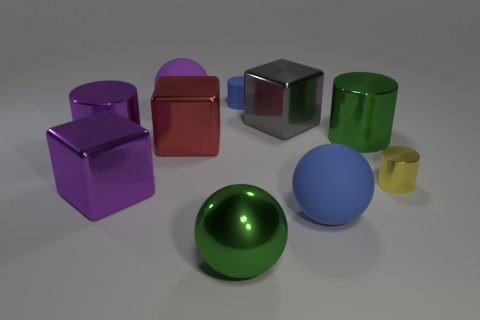Does the green sphere have the same size as the rubber thing to the right of the small matte thing?
Your response must be concise. Yes. What number of tiny things are either green metallic cylinders or purple metal blocks?
Ensure brevity in your answer.  0. What is the shape of the purple rubber object?
Offer a very short reply. Sphere. The matte sphere that is the same color as the small rubber object is what size?
Your response must be concise. Large. Are there any big red cubes that have the same material as the gray thing?
Give a very brief answer. Yes. Is the number of gray shiny blocks greater than the number of small things?
Your answer should be very brief. No. Is the tiny yellow object made of the same material as the purple block?
Your answer should be compact. Yes. What number of matte objects are big purple objects or large red spheres?
Provide a short and direct response. 1. There is a rubber ball that is the same size as the purple rubber object; what is its color?
Provide a succinct answer. Blue. How many blue matte objects are the same shape as the big gray metallic thing?
Provide a succinct answer. 0. 